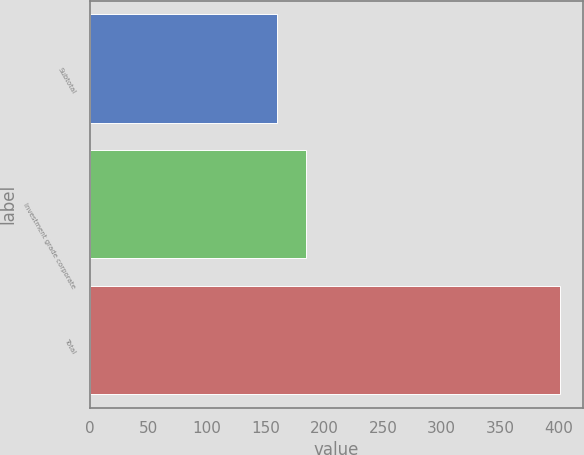Convert chart. <chart><loc_0><loc_0><loc_500><loc_500><bar_chart><fcel>Subtotal<fcel>Investment grade corporate<fcel>Total<nl><fcel>160<fcel>184.1<fcel>401<nl></chart> 